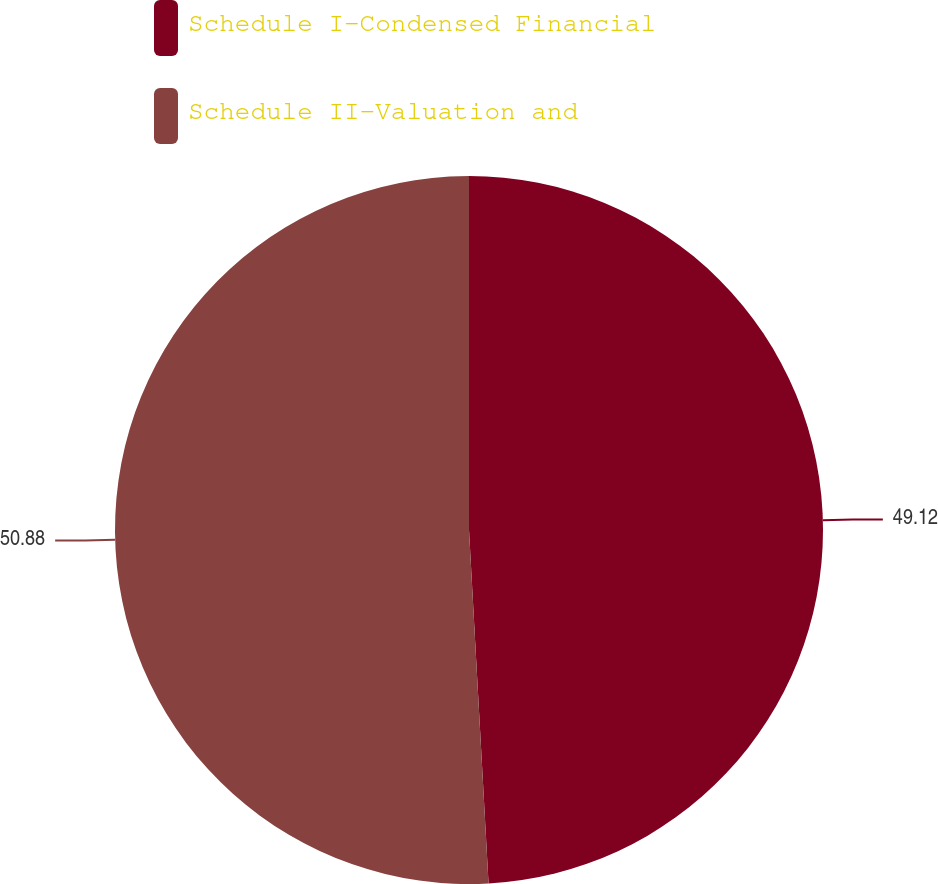Convert chart. <chart><loc_0><loc_0><loc_500><loc_500><pie_chart><fcel>Schedule I-Condensed Financial<fcel>Schedule II-Valuation and<nl><fcel>49.12%<fcel>50.88%<nl></chart> 